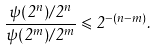<formula> <loc_0><loc_0><loc_500><loc_500>\frac { \psi ( 2 ^ { n } ) / 2 ^ { n } } { \psi ( 2 ^ { m } ) / 2 ^ { m } } \leqslant 2 ^ { - ( n - m ) } .</formula> 